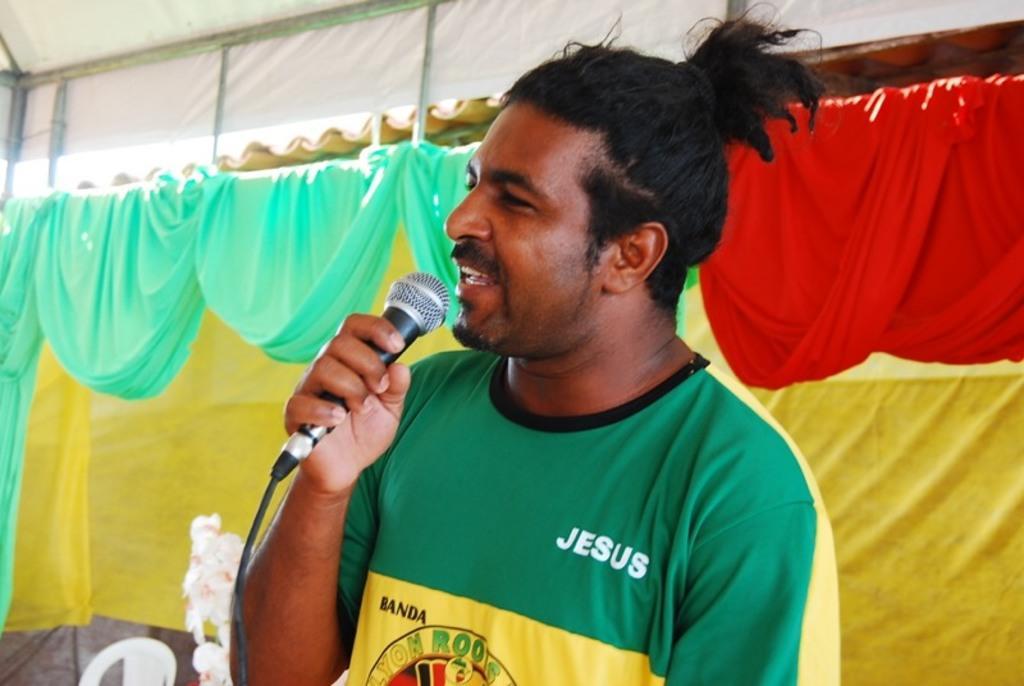Could you give a brief overview of what you see in this image? In the picture we can see a man holding a microphone, a man is wearing a green and yellow T-shirt. In the background we can find a red, blue and yellow curtain attached to the tent and we can also see a chair which is white in color. 